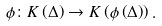Convert formula to latex. <formula><loc_0><loc_0><loc_500><loc_500>\phi \colon K \left ( \Delta \right ) \rightarrow K \left ( \phi \left ( \Delta \right ) \right ) .</formula> 